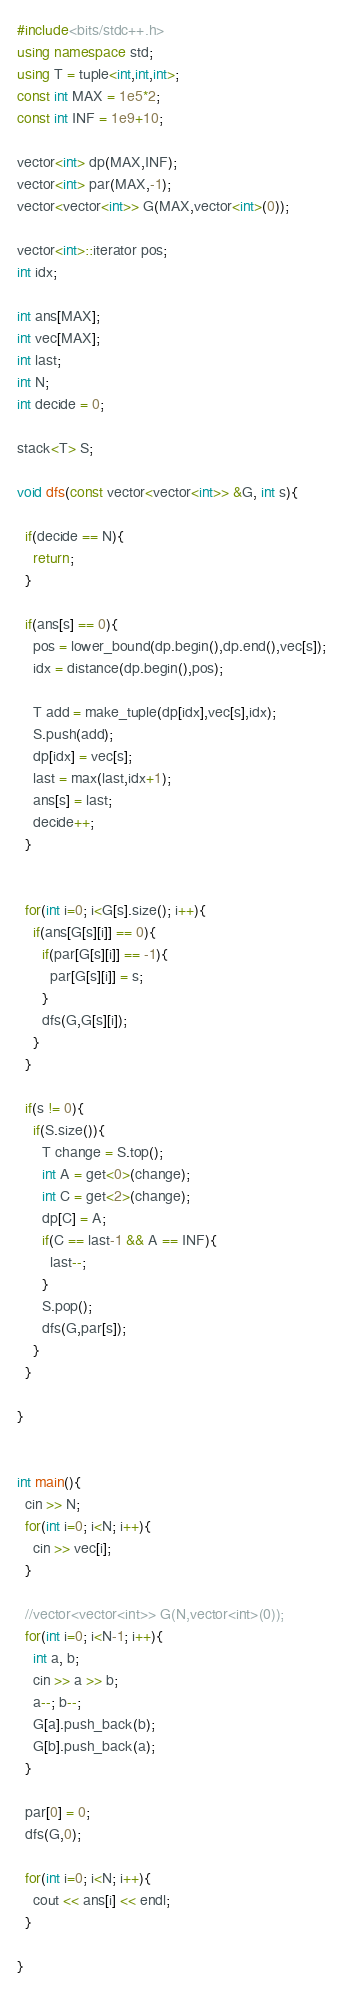<code> <loc_0><loc_0><loc_500><loc_500><_C++_>#include<bits/stdc++.h>
using namespace std;
using T = tuple<int,int,int>;
const int MAX = 1e5*2;
const int INF = 1e9+10;

vector<int> dp(MAX,INF);
vector<int> par(MAX,-1);
vector<vector<int>> G(MAX,vector<int>(0));

vector<int>::iterator pos;
int idx;

int ans[MAX];
int vec[MAX];
int last;
int N;
int decide = 0;

stack<T> S;

void dfs(const vector<vector<int>> &G, int s){
  
  if(decide == N){
    return;
  }
  
  if(ans[s] == 0){
    pos = lower_bound(dp.begin(),dp.end(),vec[s]);
    idx = distance(dp.begin(),pos);
    
    T add = make_tuple(dp[idx],vec[s],idx);
    S.push(add);
    dp[idx] = vec[s];
    last = max(last,idx+1);
    ans[s] = last;
    decide++;
  }

  
  for(int i=0; i<G[s].size(); i++){
    if(ans[G[s][i]] == 0){
      if(par[G[s][i]] == -1){
        par[G[s][i]] = s;
      }
      dfs(G,G[s][i]);
    }
  }
  
  if(s != 0){
    if(S.size()){
      T change = S.top();
      int A = get<0>(change);
      int C = get<2>(change);
      dp[C] = A;
      if(C == last-1 && A == INF){
        last--;
      }
      S.pop(); 
      dfs(G,par[s]);
    }
  }
  
}
  

int main(){
  cin >> N;
  for(int i=0; i<N; i++){
    cin >> vec[i];
  }
  
  //vector<vector<int>> G(N,vector<int>(0));
  for(int i=0; i<N-1; i++){
    int a, b;
    cin >> a >> b;
    a--; b--;
    G[a].push_back(b);
    G[b].push_back(a);
  }
  
  par[0] = 0;
  dfs(G,0);
  
  for(int i=0; i<N; i++){
    cout << ans[i] << endl;
  }
    
}</code> 